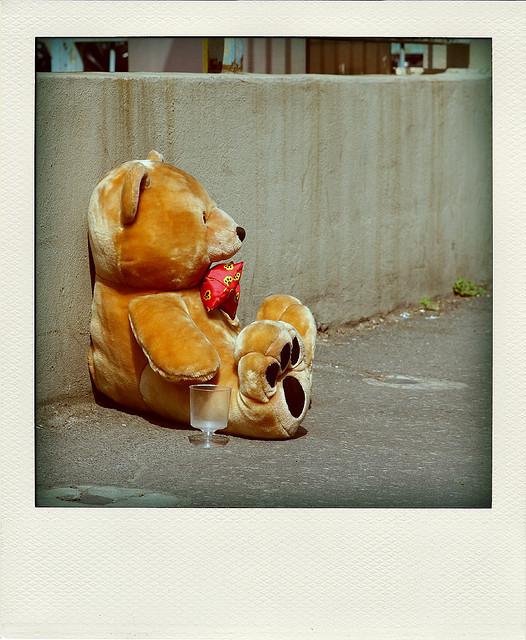What color is the bear's nose?
Answer briefly. Black. Is the teddy bear sitting?
Quick response, please. Yes. What dish is beside the bear?
Quick response, please. Glass. 